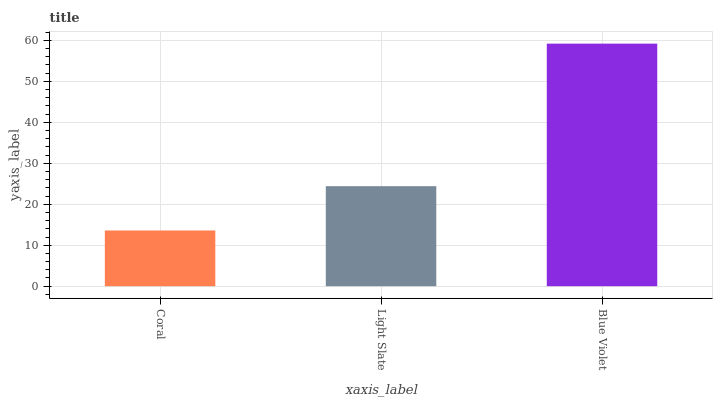Is Coral the minimum?
Answer yes or no. Yes. Is Blue Violet the maximum?
Answer yes or no. Yes. Is Light Slate the minimum?
Answer yes or no. No. Is Light Slate the maximum?
Answer yes or no. No. Is Light Slate greater than Coral?
Answer yes or no. Yes. Is Coral less than Light Slate?
Answer yes or no. Yes. Is Coral greater than Light Slate?
Answer yes or no. No. Is Light Slate less than Coral?
Answer yes or no. No. Is Light Slate the high median?
Answer yes or no. Yes. Is Light Slate the low median?
Answer yes or no. Yes. Is Coral the high median?
Answer yes or no. No. Is Coral the low median?
Answer yes or no. No. 